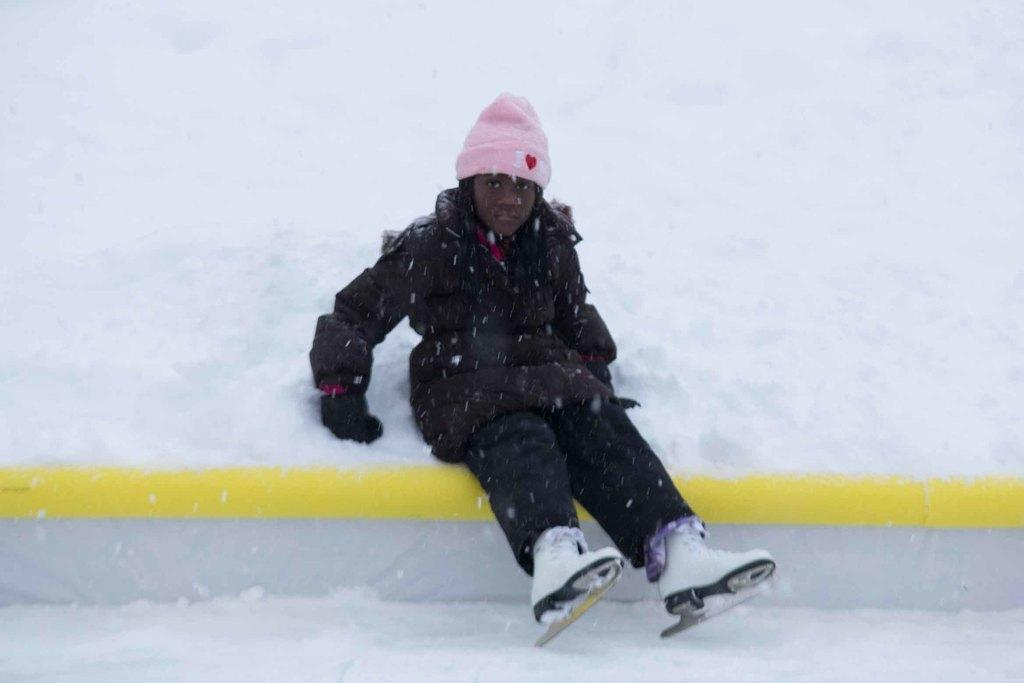What is the main subject of the image? The main subject of the image is a kid. Where is the kid located in the image? The kid is seated on the snow in the image. What type of footwear is the kid wearing? The kid is wearing ice skates in the image. What time of day is it on the stage in the image? There is no stage present in the image, and the time of day cannot be determined from the information provided. 